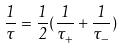<formula> <loc_0><loc_0><loc_500><loc_500>\frac { 1 } { \tau } = \frac { 1 } { 2 } ( \frac { 1 } { \tau _ { + } } + \frac { 1 } { \tau _ { - } } )</formula> 